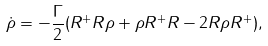Convert formula to latex. <formula><loc_0><loc_0><loc_500><loc_500>\dot { \rho } = - \frac { \Gamma } { 2 } ( R ^ { + } R \rho + \rho R ^ { + } R - 2 R \rho R ^ { + } ) ,</formula> 